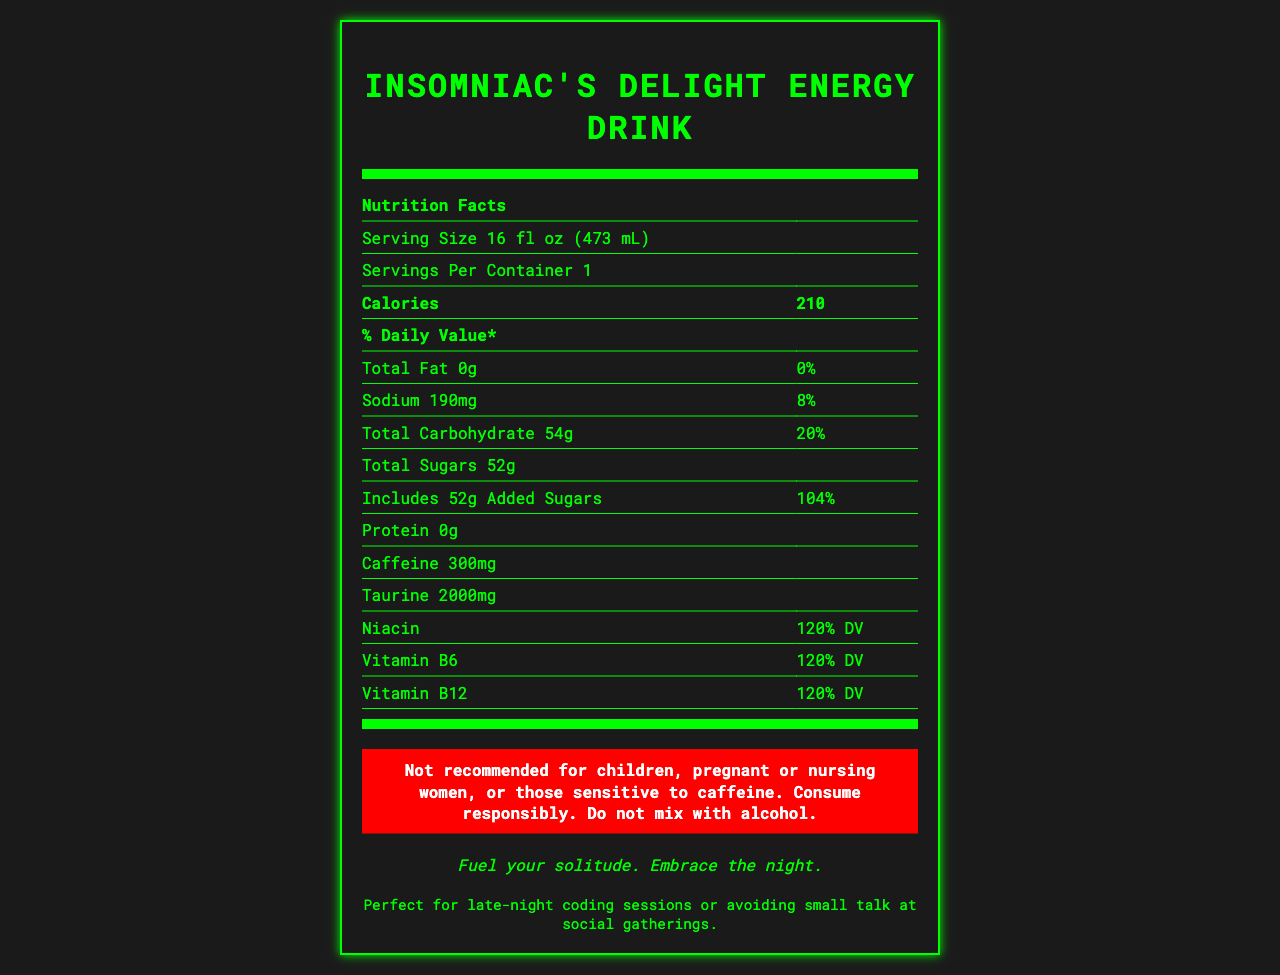what is the name of the product? The product name is prominently displayed at the top of the document in the title section.
Answer: Insomniac's Delight Energy Drink how many calories are in one serving? The document lists the number of calories as 210 in the 'Calories' section under 'Nutrition Facts'.
Answer: 210 what is the total carbohydrate content? The 'Total Carbohydrate' content is listed as 54g in the 'Nutrition Facts' table.
Answer: 54g what is the caffeine content per serving? The caffeine content per serving is specified as 300mg in the 'Nutrition Facts' table.
Answer: 300mg how much sodium is in one serving? The sodium content per serving is listed as 190mg in the 'Nutrition Facts' section.
Answer: 190mg does this product contain any dietary fiber? According to the 'Nutrition Facts,' the dietary fiber content is stated as 0g.
Answer: No which of the following vitamins are present in 120% DV in the product? A. Vitamin A, B. Niacin, C. Vitamin C, D. Folic Acid The document indicates that niacin is present at 120% DV under the 'B Vitamins' section.
Answer: B. Niacin how much added sugar does the product include? A. 52g, B. 30g, C. 40g, D. 20g The 'Includes Added Sugars' entry in the 'Nutrition Facts' table specifies 52g, which is 104% DV.
Answer: A. 52g is this drink recommended for children? The warning section explicitly states it's not recommended for children.
Answer: No what is the purpose of the product as indicated by the tagline? The marketing tagline of the product is provided at the bottom center of the document, describing the purpose succinctly.
Answer: Fuel your solitude. Embrace the night. describe the main idea of the document The document is primarily presenting detailed nutritional information for "Insomniac's Delight Energy Drink," emphasizing its role as a high-caffeine energy drink through listed ingredients and nutritional values, with additional sections for warnings and marketing.
Answer: The document provides the nutrition facts of "Insomniac's Delight Energy Drink," highlighting its high caffeine content, calorie count, and ingredients. It also includes a warning, a marketing tagline, and a consumer note. what is the amount of potassium per serving? The 'Nutrition Facts' table specifies the potassium content per serving as 85mg.
Answer: 85mg can the vitamin D content of the product be determined from the document? The vitamin D content is listed as 0mcg in the 'Nutrition Facts' table.
Answer: 0mcg is the product suitable for mixing with alcohol? The warning section advises against mixing the product with alcohol.
Answer: No what are some of the main artificial ingredients listed? Under 'Other Ingredients,' High Fructose Corn Syrup and Citric Acid are among the main artificial ingredients listed.
Answer: High Fructose Corn Syrup, Citric Acid what is the total fat content of the product? The 'Nutrition Facts' table states the total fat content is 0g.
Answer: 0g according to the consumer note, what activity is the energy drink perfect for? The consumer note mentions these activities specifically at the bottom of the document.
Answer: Late-night coding sessions or avoiding small talk at social gatherings how much protein is in the drink? The 'Nutrition Facts' section lists the protein content as 0g.
Answer: 0g does the document specify exact amounts for all B vitamins? The document provides percentage daily values (120% DV) but does not provide the exact amounts for each B vitamin (niacin, vitamin B6, and vitamin B12).
Answer: No what does the warning say about people who are sensitive to caffeine? The warning explicitly says, "Not recommended for... those sensitive to caffeine."
Answer: They should not consume the product. 